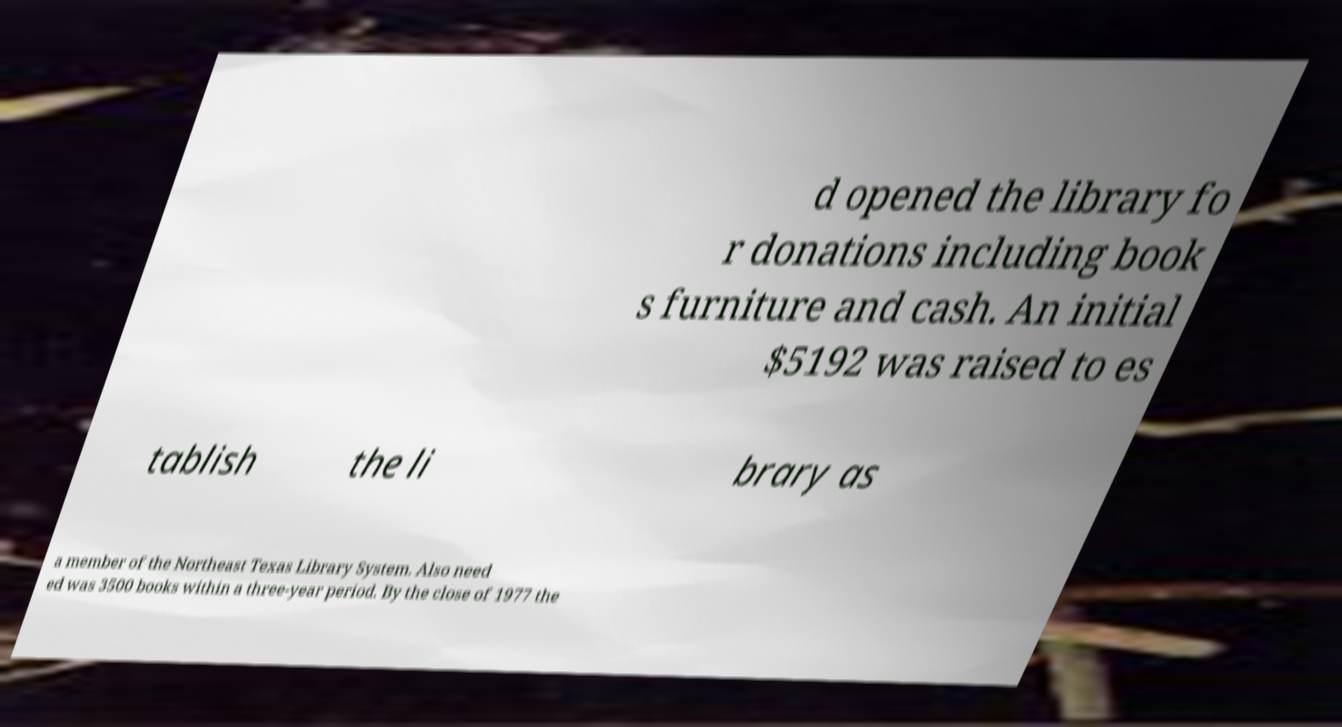There's text embedded in this image that I need extracted. Can you transcribe it verbatim? d opened the library fo r donations including book s furniture and cash. An initial $5192 was raised to es tablish the li brary as a member of the Northeast Texas Library System. Also need ed was 3500 books within a three-year period. By the close of 1977 the 